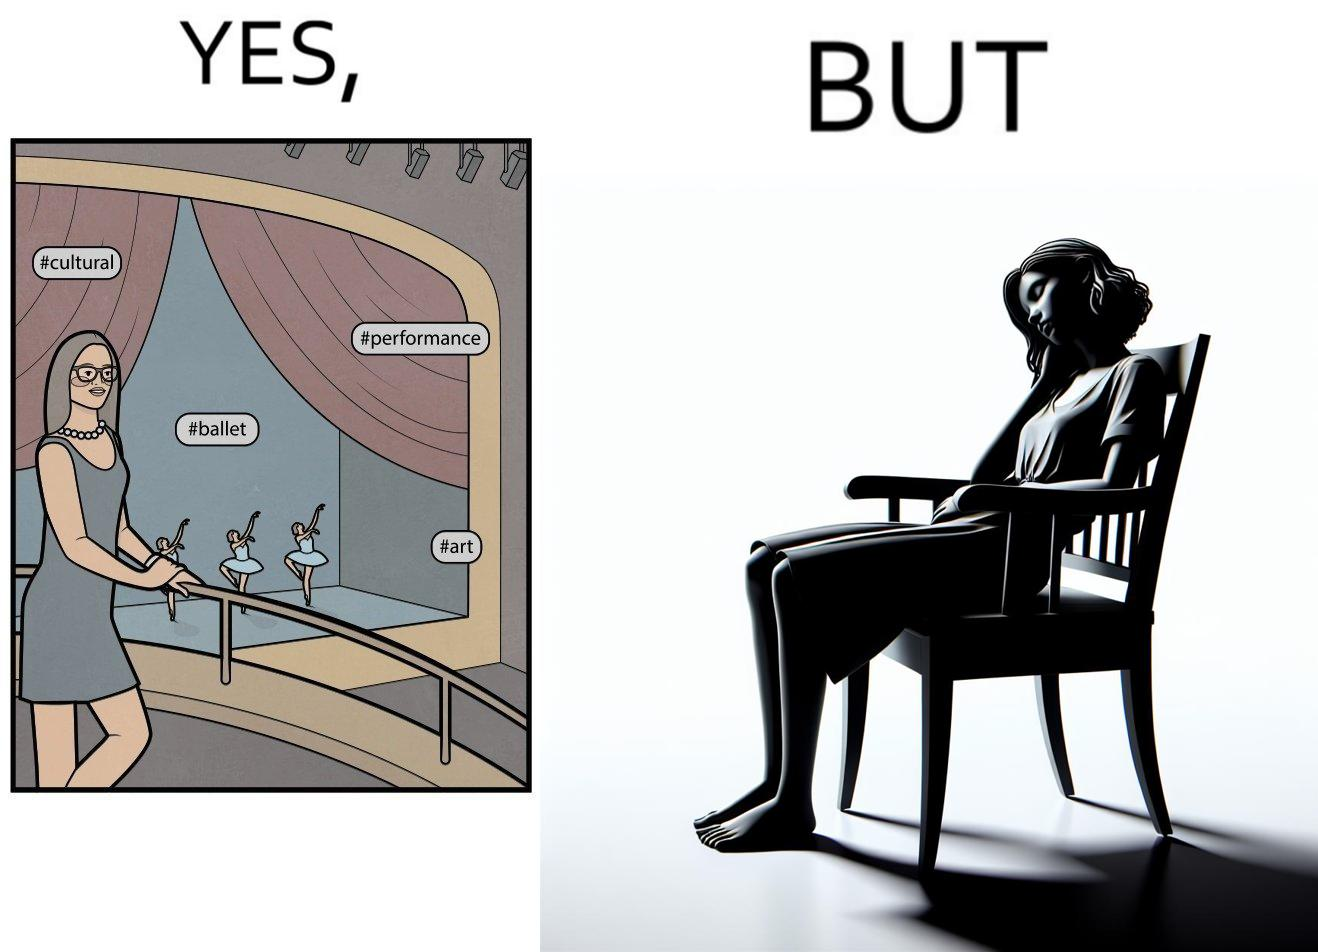Explain why this image is satirical. The image is ironic, because in the first image the woman is trying to show off how much she likes ballet dance performance by posting a photo attending some program but in the same program she is seen sleeping on the chair 